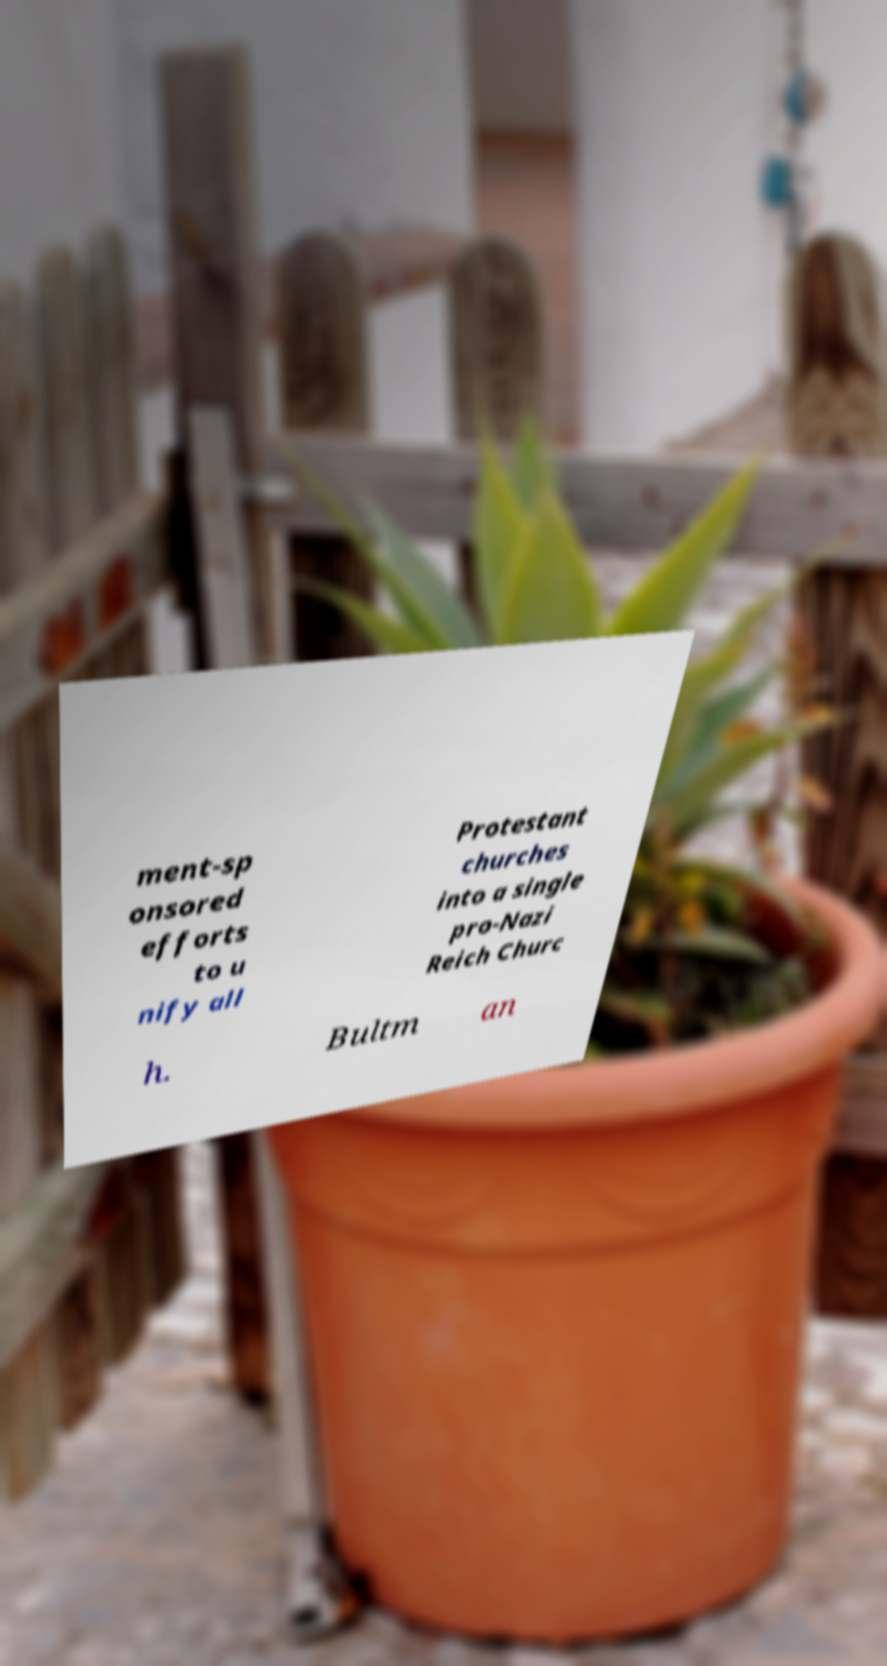There's text embedded in this image that I need extracted. Can you transcribe it verbatim? ment-sp onsored efforts to u nify all Protestant churches into a single pro-Nazi Reich Churc h. Bultm an 